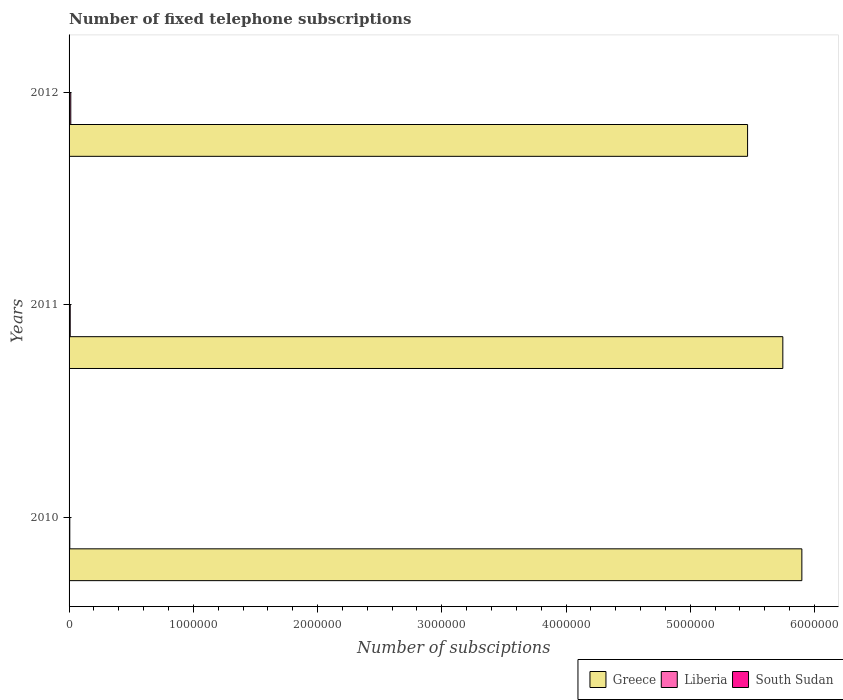How many groups of bars are there?
Your answer should be very brief. 3. Are the number of bars per tick equal to the number of legend labels?
Your answer should be very brief. Yes. How many bars are there on the 3rd tick from the bottom?
Your response must be concise. 3. What is the label of the 2nd group of bars from the top?
Your answer should be very brief. 2011. What is the number of fixed telephone subscriptions in Liberia in 2012?
Offer a terse response. 1.37e+04. Across all years, what is the maximum number of fixed telephone subscriptions in Greece?
Provide a short and direct response. 5.90e+06. Across all years, what is the minimum number of fixed telephone subscriptions in South Sudan?
Your answer should be very brief. 150. In which year was the number of fixed telephone subscriptions in Liberia minimum?
Provide a succinct answer. 2010. What is the total number of fixed telephone subscriptions in South Sudan in the graph?
Your response must be concise. 4750. What is the difference between the number of fixed telephone subscriptions in Greece in 2011 and that in 2012?
Make the answer very short. 2.84e+05. What is the difference between the number of fixed telephone subscriptions in Greece in 2011 and the number of fixed telephone subscriptions in South Sudan in 2012?
Offer a terse response. 5.74e+06. What is the average number of fixed telephone subscriptions in Liberia per year?
Provide a short and direct response. 9609.67. In the year 2012, what is the difference between the number of fixed telephone subscriptions in Greece and number of fixed telephone subscriptions in Liberia?
Give a very brief answer. 5.45e+06. What is the ratio of the number of fixed telephone subscriptions in Liberia in 2010 to that in 2012?
Provide a short and direct response. 0.42. Is the number of fixed telephone subscriptions in South Sudan in 2010 less than that in 2012?
Make the answer very short. No. Is the difference between the number of fixed telephone subscriptions in Greece in 2011 and 2012 greater than the difference between the number of fixed telephone subscriptions in Liberia in 2011 and 2012?
Give a very brief answer. Yes. What is the difference between the highest and the second highest number of fixed telephone subscriptions in Greece?
Your answer should be very brief. 1.53e+05. What is the difference between the highest and the lowest number of fixed telephone subscriptions in South Sudan?
Your answer should be very brief. 2250. Is the sum of the number of fixed telephone subscriptions in South Sudan in 2010 and 2011 greater than the maximum number of fixed telephone subscriptions in Liberia across all years?
Offer a terse response. No. What does the 2nd bar from the top in 2010 represents?
Your response must be concise. Liberia. What does the 1st bar from the bottom in 2010 represents?
Offer a very short reply. Greece. Is it the case that in every year, the sum of the number of fixed telephone subscriptions in Liberia and number of fixed telephone subscriptions in Greece is greater than the number of fixed telephone subscriptions in South Sudan?
Offer a very short reply. Yes. Are all the bars in the graph horizontal?
Ensure brevity in your answer.  Yes. Are the values on the major ticks of X-axis written in scientific E-notation?
Make the answer very short. No. Where does the legend appear in the graph?
Provide a succinct answer. Bottom right. What is the title of the graph?
Offer a very short reply. Number of fixed telephone subscriptions. What is the label or title of the X-axis?
Make the answer very short. Number of subsciptions. What is the Number of subsciptions of Greece in 2010?
Offer a very short reply. 5.90e+06. What is the Number of subsciptions in Liberia in 2010?
Keep it short and to the point. 5806. What is the Number of subsciptions in South Sudan in 2010?
Offer a very short reply. 2400. What is the Number of subsciptions of Greece in 2011?
Your response must be concise. 5.74e+06. What is the Number of subsciptions in Liberia in 2011?
Your answer should be very brief. 9289. What is the Number of subsciptions of South Sudan in 2011?
Your answer should be compact. 2200. What is the Number of subsciptions of Greece in 2012?
Ensure brevity in your answer.  5.46e+06. What is the Number of subsciptions of Liberia in 2012?
Offer a terse response. 1.37e+04. What is the Number of subsciptions in South Sudan in 2012?
Give a very brief answer. 150. Across all years, what is the maximum Number of subsciptions in Greece?
Offer a terse response. 5.90e+06. Across all years, what is the maximum Number of subsciptions in Liberia?
Keep it short and to the point. 1.37e+04. Across all years, what is the maximum Number of subsciptions in South Sudan?
Provide a succinct answer. 2400. Across all years, what is the minimum Number of subsciptions of Greece?
Provide a succinct answer. 5.46e+06. Across all years, what is the minimum Number of subsciptions in Liberia?
Provide a short and direct response. 5806. Across all years, what is the minimum Number of subsciptions in South Sudan?
Make the answer very short. 150. What is the total Number of subsciptions in Greece in the graph?
Your answer should be very brief. 1.71e+07. What is the total Number of subsciptions of Liberia in the graph?
Offer a terse response. 2.88e+04. What is the total Number of subsciptions of South Sudan in the graph?
Offer a terse response. 4750. What is the difference between the Number of subsciptions in Greece in 2010 and that in 2011?
Your response must be concise. 1.53e+05. What is the difference between the Number of subsciptions of Liberia in 2010 and that in 2011?
Offer a very short reply. -3483. What is the difference between the Number of subsciptions in Greece in 2010 and that in 2012?
Make the answer very short. 4.37e+05. What is the difference between the Number of subsciptions in Liberia in 2010 and that in 2012?
Provide a short and direct response. -7928. What is the difference between the Number of subsciptions of South Sudan in 2010 and that in 2012?
Provide a short and direct response. 2250. What is the difference between the Number of subsciptions of Greece in 2011 and that in 2012?
Your response must be concise. 2.84e+05. What is the difference between the Number of subsciptions of Liberia in 2011 and that in 2012?
Offer a terse response. -4445. What is the difference between the Number of subsciptions of South Sudan in 2011 and that in 2012?
Keep it short and to the point. 2050. What is the difference between the Number of subsciptions in Greece in 2010 and the Number of subsciptions in Liberia in 2011?
Make the answer very short. 5.89e+06. What is the difference between the Number of subsciptions of Greece in 2010 and the Number of subsciptions of South Sudan in 2011?
Offer a terse response. 5.90e+06. What is the difference between the Number of subsciptions of Liberia in 2010 and the Number of subsciptions of South Sudan in 2011?
Ensure brevity in your answer.  3606. What is the difference between the Number of subsciptions of Greece in 2010 and the Number of subsciptions of Liberia in 2012?
Your answer should be very brief. 5.88e+06. What is the difference between the Number of subsciptions of Greece in 2010 and the Number of subsciptions of South Sudan in 2012?
Give a very brief answer. 5.90e+06. What is the difference between the Number of subsciptions of Liberia in 2010 and the Number of subsciptions of South Sudan in 2012?
Your answer should be very brief. 5656. What is the difference between the Number of subsciptions in Greece in 2011 and the Number of subsciptions in Liberia in 2012?
Offer a very short reply. 5.73e+06. What is the difference between the Number of subsciptions of Greece in 2011 and the Number of subsciptions of South Sudan in 2012?
Your answer should be compact. 5.74e+06. What is the difference between the Number of subsciptions of Liberia in 2011 and the Number of subsciptions of South Sudan in 2012?
Offer a terse response. 9139. What is the average Number of subsciptions in Greece per year?
Offer a very short reply. 5.70e+06. What is the average Number of subsciptions of Liberia per year?
Your answer should be very brief. 9609.67. What is the average Number of subsciptions in South Sudan per year?
Give a very brief answer. 1583.33. In the year 2010, what is the difference between the Number of subsciptions in Greece and Number of subsciptions in Liberia?
Your answer should be very brief. 5.89e+06. In the year 2010, what is the difference between the Number of subsciptions of Greece and Number of subsciptions of South Sudan?
Provide a short and direct response. 5.90e+06. In the year 2010, what is the difference between the Number of subsciptions in Liberia and Number of subsciptions in South Sudan?
Make the answer very short. 3406. In the year 2011, what is the difference between the Number of subsciptions in Greece and Number of subsciptions in Liberia?
Offer a very short reply. 5.74e+06. In the year 2011, what is the difference between the Number of subsciptions of Greece and Number of subsciptions of South Sudan?
Provide a short and direct response. 5.74e+06. In the year 2011, what is the difference between the Number of subsciptions of Liberia and Number of subsciptions of South Sudan?
Give a very brief answer. 7089. In the year 2012, what is the difference between the Number of subsciptions of Greece and Number of subsciptions of Liberia?
Give a very brief answer. 5.45e+06. In the year 2012, what is the difference between the Number of subsciptions in Greece and Number of subsciptions in South Sudan?
Keep it short and to the point. 5.46e+06. In the year 2012, what is the difference between the Number of subsciptions of Liberia and Number of subsciptions of South Sudan?
Offer a terse response. 1.36e+04. What is the ratio of the Number of subsciptions of Greece in 2010 to that in 2011?
Your answer should be compact. 1.03. What is the ratio of the Number of subsciptions in Liberia in 2010 to that in 2012?
Keep it short and to the point. 0.42. What is the ratio of the Number of subsciptions in South Sudan in 2010 to that in 2012?
Give a very brief answer. 16. What is the ratio of the Number of subsciptions in Greece in 2011 to that in 2012?
Keep it short and to the point. 1.05. What is the ratio of the Number of subsciptions of Liberia in 2011 to that in 2012?
Provide a succinct answer. 0.68. What is the ratio of the Number of subsciptions in South Sudan in 2011 to that in 2012?
Your answer should be compact. 14.67. What is the difference between the highest and the second highest Number of subsciptions in Greece?
Ensure brevity in your answer.  1.53e+05. What is the difference between the highest and the second highest Number of subsciptions of Liberia?
Provide a succinct answer. 4445. What is the difference between the highest and the second highest Number of subsciptions in South Sudan?
Offer a very short reply. 200. What is the difference between the highest and the lowest Number of subsciptions of Greece?
Give a very brief answer. 4.37e+05. What is the difference between the highest and the lowest Number of subsciptions of Liberia?
Make the answer very short. 7928. What is the difference between the highest and the lowest Number of subsciptions in South Sudan?
Your answer should be compact. 2250. 